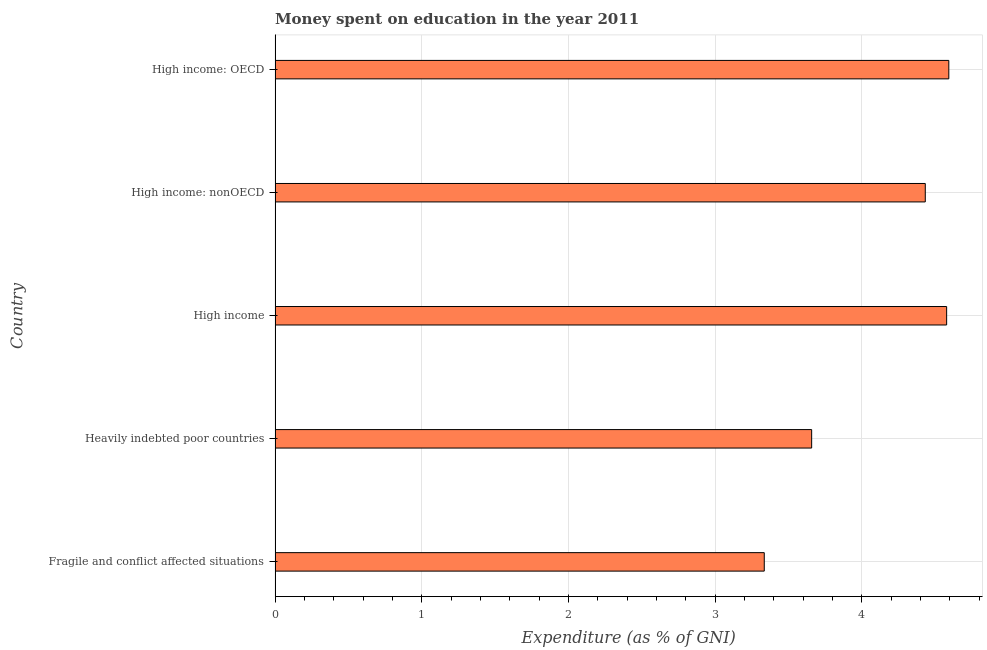Does the graph contain any zero values?
Offer a terse response. No. Does the graph contain grids?
Give a very brief answer. Yes. What is the title of the graph?
Your answer should be very brief. Money spent on education in the year 2011. What is the label or title of the X-axis?
Your response must be concise. Expenditure (as % of GNI). What is the label or title of the Y-axis?
Provide a succinct answer. Country. What is the expenditure on education in High income?
Make the answer very short. 4.58. Across all countries, what is the maximum expenditure on education?
Your response must be concise. 4.59. Across all countries, what is the minimum expenditure on education?
Provide a succinct answer. 3.34. In which country was the expenditure on education maximum?
Your answer should be compact. High income: OECD. In which country was the expenditure on education minimum?
Make the answer very short. Fragile and conflict affected situations. What is the sum of the expenditure on education?
Offer a terse response. 20.6. What is the difference between the expenditure on education in High income and High income: nonOECD?
Offer a very short reply. 0.15. What is the average expenditure on education per country?
Give a very brief answer. 4.12. What is the median expenditure on education?
Offer a terse response. 4.43. In how many countries, is the expenditure on education greater than 2.8 %?
Ensure brevity in your answer.  5. What is the ratio of the expenditure on education in Fragile and conflict affected situations to that in High income: OECD?
Ensure brevity in your answer.  0.73. Is the expenditure on education in Heavily indebted poor countries less than that in High income?
Provide a short and direct response. Yes. What is the difference between the highest and the second highest expenditure on education?
Offer a very short reply. 0.01. Is the sum of the expenditure on education in Fragile and conflict affected situations and High income: nonOECD greater than the maximum expenditure on education across all countries?
Provide a short and direct response. Yes. What is the difference between the highest and the lowest expenditure on education?
Your answer should be compact. 1.26. In how many countries, is the expenditure on education greater than the average expenditure on education taken over all countries?
Provide a succinct answer. 3. What is the difference between two consecutive major ticks on the X-axis?
Offer a very short reply. 1. Are the values on the major ticks of X-axis written in scientific E-notation?
Your answer should be compact. No. What is the Expenditure (as % of GNI) in Fragile and conflict affected situations?
Provide a succinct answer. 3.34. What is the Expenditure (as % of GNI) of Heavily indebted poor countries?
Provide a succinct answer. 3.66. What is the Expenditure (as % of GNI) in High income?
Give a very brief answer. 4.58. What is the Expenditure (as % of GNI) of High income: nonOECD?
Make the answer very short. 4.43. What is the Expenditure (as % of GNI) in High income: OECD?
Ensure brevity in your answer.  4.59. What is the difference between the Expenditure (as % of GNI) in Fragile and conflict affected situations and Heavily indebted poor countries?
Your answer should be very brief. -0.32. What is the difference between the Expenditure (as % of GNI) in Fragile and conflict affected situations and High income?
Ensure brevity in your answer.  -1.24. What is the difference between the Expenditure (as % of GNI) in Fragile and conflict affected situations and High income: nonOECD?
Offer a very short reply. -1.1. What is the difference between the Expenditure (as % of GNI) in Fragile and conflict affected situations and High income: OECD?
Give a very brief answer. -1.26. What is the difference between the Expenditure (as % of GNI) in Heavily indebted poor countries and High income?
Provide a succinct answer. -0.92. What is the difference between the Expenditure (as % of GNI) in Heavily indebted poor countries and High income: nonOECD?
Provide a short and direct response. -0.77. What is the difference between the Expenditure (as % of GNI) in Heavily indebted poor countries and High income: OECD?
Keep it short and to the point. -0.94. What is the difference between the Expenditure (as % of GNI) in High income and High income: nonOECD?
Make the answer very short. 0.15. What is the difference between the Expenditure (as % of GNI) in High income and High income: OECD?
Make the answer very short. -0.01. What is the difference between the Expenditure (as % of GNI) in High income: nonOECD and High income: OECD?
Provide a short and direct response. -0.16. What is the ratio of the Expenditure (as % of GNI) in Fragile and conflict affected situations to that in Heavily indebted poor countries?
Ensure brevity in your answer.  0.91. What is the ratio of the Expenditure (as % of GNI) in Fragile and conflict affected situations to that in High income?
Provide a short and direct response. 0.73. What is the ratio of the Expenditure (as % of GNI) in Fragile and conflict affected situations to that in High income: nonOECD?
Give a very brief answer. 0.75. What is the ratio of the Expenditure (as % of GNI) in Fragile and conflict affected situations to that in High income: OECD?
Offer a terse response. 0.73. What is the ratio of the Expenditure (as % of GNI) in Heavily indebted poor countries to that in High income?
Provide a short and direct response. 0.8. What is the ratio of the Expenditure (as % of GNI) in Heavily indebted poor countries to that in High income: nonOECD?
Your response must be concise. 0.82. What is the ratio of the Expenditure (as % of GNI) in Heavily indebted poor countries to that in High income: OECD?
Provide a short and direct response. 0.8. What is the ratio of the Expenditure (as % of GNI) in High income to that in High income: nonOECD?
Provide a succinct answer. 1.03. What is the ratio of the Expenditure (as % of GNI) in High income to that in High income: OECD?
Ensure brevity in your answer.  1. What is the ratio of the Expenditure (as % of GNI) in High income: nonOECD to that in High income: OECD?
Offer a terse response. 0.96. 